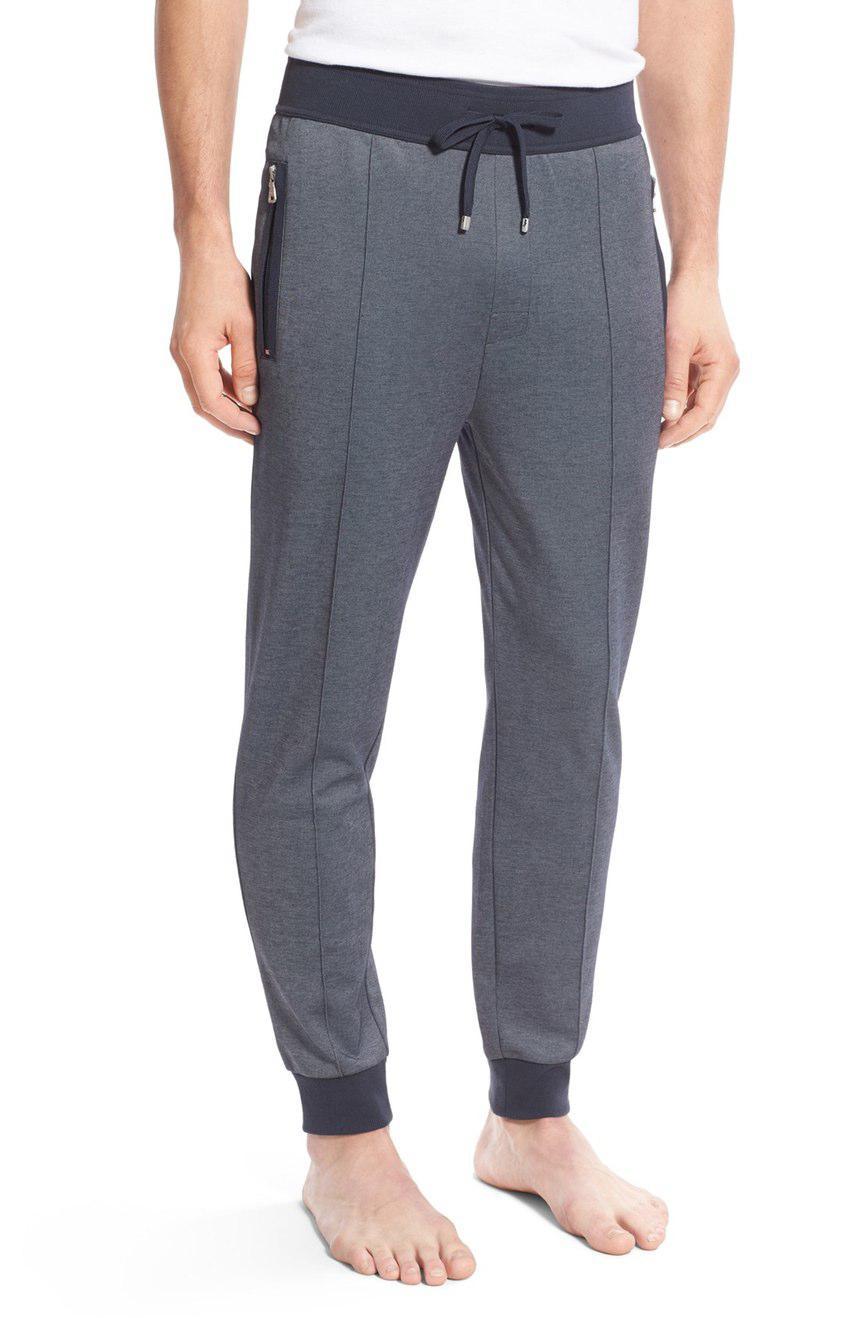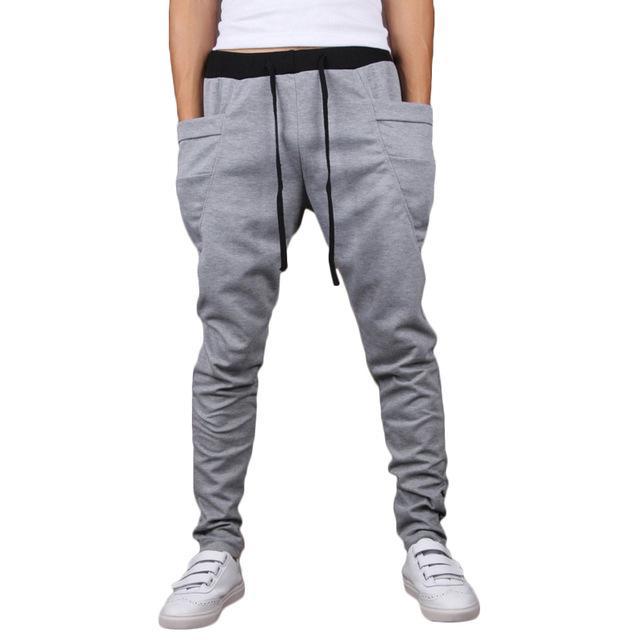The first image is the image on the left, the second image is the image on the right. Examine the images to the left and right. Is the description "One of two models shown is wearing shoes and the other is barefoot." accurate? Answer yes or no. Yes. 